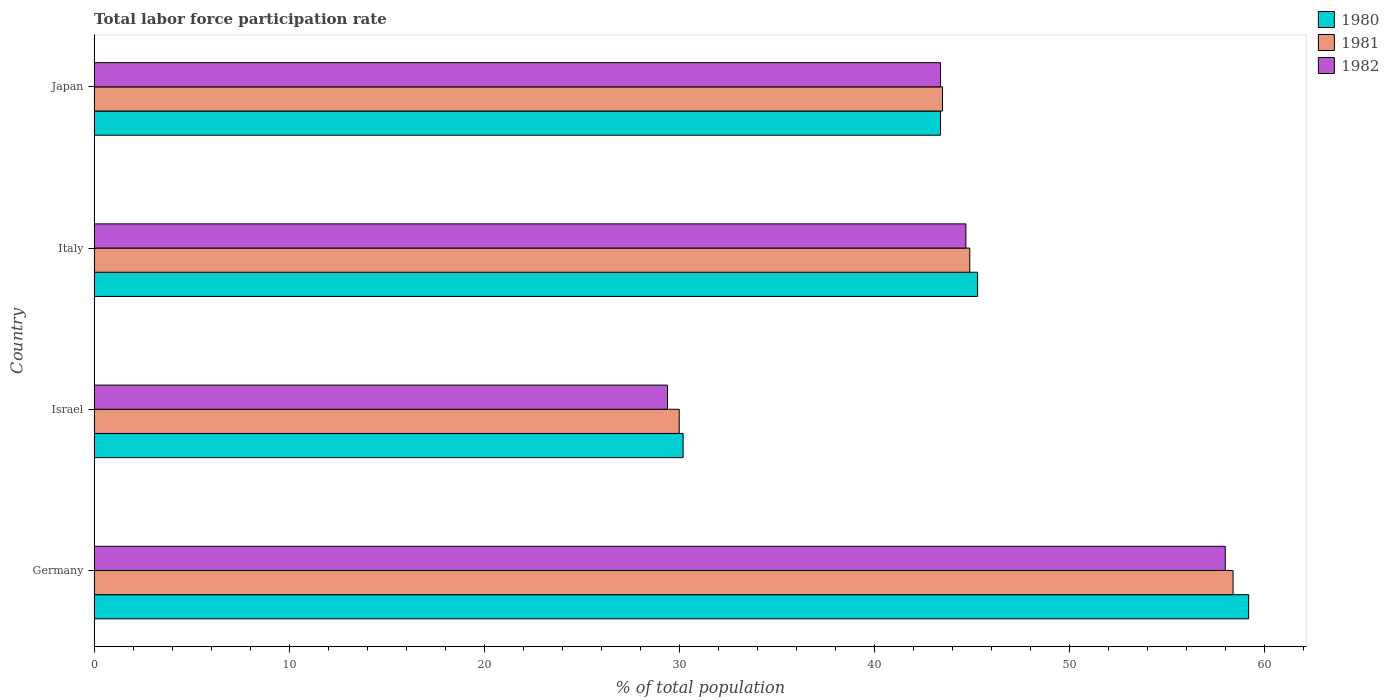How many different coloured bars are there?
Ensure brevity in your answer.  3. How many groups of bars are there?
Your answer should be compact. 4. Are the number of bars per tick equal to the number of legend labels?
Your answer should be very brief. Yes. How many bars are there on the 1st tick from the bottom?
Give a very brief answer. 3. In how many cases, is the number of bars for a given country not equal to the number of legend labels?
Give a very brief answer. 0. What is the total labor force participation rate in 1980 in Japan?
Offer a terse response. 43.4. Across all countries, what is the maximum total labor force participation rate in 1981?
Provide a succinct answer. 58.4. In which country was the total labor force participation rate in 1981 maximum?
Your response must be concise. Germany. What is the total total labor force participation rate in 1981 in the graph?
Keep it short and to the point. 176.8. What is the difference between the total labor force participation rate in 1982 in Germany and that in Japan?
Your answer should be very brief. 14.6. What is the difference between the total labor force participation rate in 1980 in Israel and the total labor force participation rate in 1982 in Italy?
Your response must be concise. -14.5. What is the average total labor force participation rate in 1980 per country?
Your answer should be very brief. 44.53. What is the difference between the total labor force participation rate in 1981 and total labor force participation rate in 1980 in Germany?
Offer a terse response. -0.8. What is the ratio of the total labor force participation rate in 1981 in Italy to that in Japan?
Your response must be concise. 1.03. Is the total labor force participation rate in 1980 in Germany less than that in Israel?
Provide a short and direct response. No. Is the difference between the total labor force participation rate in 1981 in Germany and Italy greater than the difference between the total labor force participation rate in 1980 in Germany and Italy?
Your response must be concise. No. What is the difference between the highest and the lowest total labor force participation rate in 1982?
Offer a terse response. 28.6. Is the sum of the total labor force participation rate in 1980 in Italy and Japan greater than the maximum total labor force participation rate in 1982 across all countries?
Make the answer very short. Yes. What does the 1st bar from the bottom in Germany represents?
Make the answer very short. 1980. Is it the case that in every country, the sum of the total labor force participation rate in 1981 and total labor force participation rate in 1980 is greater than the total labor force participation rate in 1982?
Provide a succinct answer. Yes. How many bars are there?
Make the answer very short. 12. Are all the bars in the graph horizontal?
Your answer should be compact. Yes. Are the values on the major ticks of X-axis written in scientific E-notation?
Give a very brief answer. No. Does the graph contain any zero values?
Your answer should be compact. No. Where does the legend appear in the graph?
Keep it short and to the point. Top right. How are the legend labels stacked?
Your response must be concise. Vertical. What is the title of the graph?
Make the answer very short. Total labor force participation rate. What is the label or title of the X-axis?
Keep it short and to the point. % of total population. What is the label or title of the Y-axis?
Your answer should be very brief. Country. What is the % of total population in 1980 in Germany?
Make the answer very short. 59.2. What is the % of total population of 1981 in Germany?
Make the answer very short. 58.4. What is the % of total population in 1982 in Germany?
Offer a very short reply. 58. What is the % of total population of 1980 in Israel?
Provide a short and direct response. 30.2. What is the % of total population in 1981 in Israel?
Your response must be concise. 30. What is the % of total population of 1982 in Israel?
Ensure brevity in your answer.  29.4. What is the % of total population of 1980 in Italy?
Your answer should be compact. 45.3. What is the % of total population of 1981 in Italy?
Keep it short and to the point. 44.9. What is the % of total population in 1982 in Italy?
Provide a short and direct response. 44.7. What is the % of total population of 1980 in Japan?
Your response must be concise. 43.4. What is the % of total population in 1981 in Japan?
Your answer should be very brief. 43.5. What is the % of total population of 1982 in Japan?
Provide a succinct answer. 43.4. Across all countries, what is the maximum % of total population in 1980?
Your response must be concise. 59.2. Across all countries, what is the maximum % of total population in 1981?
Provide a succinct answer. 58.4. Across all countries, what is the minimum % of total population of 1980?
Provide a short and direct response. 30.2. Across all countries, what is the minimum % of total population of 1982?
Offer a terse response. 29.4. What is the total % of total population of 1980 in the graph?
Give a very brief answer. 178.1. What is the total % of total population in 1981 in the graph?
Provide a succinct answer. 176.8. What is the total % of total population of 1982 in the graph?
Give a very brief answer. 175.5. What is the difference between the % of total population in 1980 in Germany and that in Israel?
Give a very brief answer. 29. What is the difference between the % of total population of 1981 in Germany and that in Israel?
Give a very brief answer. 28.4. What is the difference between the % of total population in 1982 in Germany and that in Israel?
Give a very brief answer. 28.6. What is the difference between the % of total population of 1980 in Germany and that in Italy?
Your response must be concise. 13.9. What is the difference between the % of total population of 1980 in Germany and that in Japan?
Provide a succinct answer. 15.8. What is the difference between the % of total population in 1981 in Germany and that in Japan?
Keep it short and to the point. 14.9. What is the difference between the % of total population in 1980 in Israel and that in Italy?
Provide a short and direct response. -15.1. What is the difference between the % of total population of 1981 in Israel and that in Italy?
Ensure brevity in your answer.  -14.9. What is the difference between the % of total population of 1982 in Israel and that in Italy?
Offer a very short reply. -15.3. What is the difference between the % of total population of 1980 in Israel and that in Japan?
Your response must be concise. -13.2. What is the difference between the % of total population in 1981 in Israel and that in Japan?
Give a very brief answer. -13.5. What is the difference between the % of total population in 1982 in Israel and that in Japan?
Provide a succinct answer. -14. What is the difference between the % of total population in 1981 in Italy and that in Japan?
Ensure brevity in your answer.  1.4. What is the difference between the % of total population in 1980 in Germany and the % of total population in 1981 in Israel?
Provide a short and direct response. 29.2. What is the difference between the % of total population of 1980 in Germany and the % of total population of 1982 in Israel?
Your response must be concise. 29.8. What is the difference between the % of total population in 1981 in Germany and the % of total population in 1982 in Israel?
Provide a succinct answer. 29. What is the difference between the % of total population of 1980 in Germany and the % of total population of 1981 in Italy?
Provide a succinct answer. 14.3. What is the difference between the % of total population of 1980 in Germany and the % of total population of 1982 in Italy?
Offer a very short reply. 14.5. What is the difference between the % of total population of 1980 in Germany and the % of total population of 1981 in Japan?
Ensure brevity in your answer.  15.7. What is the difference between the % of total population in 1981 in Germany and the % of total population in 1982 in Japan?
Your answer should be compact. 15. What is the difference between the % of total population in 1980 in Israel and the % of total population in 1981 in Italy?
Provide a succinct answer. -14.7. What is the difference between the % of total population of 1980 in Israel and the % of total population of 1982 in Italy?
Your answer should be compact. -14.5. What is the difference between the % of total population of 1981 in Israel and the % of total population of 1982 in Italy?
Your answer should be very brief. -14.7. What is the difference between the % of total population in 1980 in Israel and the % of total population in 1982 in Japan?
Give a very brief answer. -13.2. What is the difference between the % of total population in 1981 in Israel and the % of total population in 1982 in Japan?
Keep it short and to the point. -13.4. What is the difference between the % of total population of 1980 in Italy and the % of total population of 1982 in Japan?
Give a very brief answer. 1.9. What is the average % of total population in 1980 per country?
Your answer should be compact. 44.52. What is the average % of total population in 1981 per country?
Offer a terse response. 44.2. What is the average % of total population in 1982 per country?
Offer a terse response. 43.88. What is the difference between the % of total population of 1980 and % of total population of 1981 in Germany?
Provide a succinct answer. 0.8. What is the difference between the % of total population in 1980 and % of total population in 1981 in Israel?
Your answer should be compact. 0.2. What is the difference between the % of total population of 1980 and % of total population of 1981 in Italy?
Ensure brevity in your answer.  0.4. What is the difference between the % of total population of 1980 and % of total population of 1982 in Italy?
Offer a very short reply. 0.6. What is the difference between the % of total population in 1981 and % of total population in 1982 in Japan?
Offer a terse response. 0.1. What is the ratio of the % of total population in 1980 in Germany to that in Israel?
Ensure brevity in your answer.  1.96. What is the ratio of the % of total population in 1981 in Germany to that in Israel?
Your answer should be compact. 1.95. What is the ratio of the % of total population in 1982 in Germany to that in Israel?
Keep it short and to the point. 1.97. What is the ratio of the % of total population of 1980 in Germany to that in Italy?
Your answer should be very brief. 1.31. What is the ratio of the % of total population in 1981 in Germany to that in Italy?
Provide a succinct answer. 1.3. What is the ratio of the % of total population in 1982 in Germany to that in Italy?
Your answer should be very brief. 1.3. What is the ratio of the % of total population in 1980 in Germany to that in Japan?
Offer a terse response. 1.36. What is the ratio of the % of total population in 1981 in Germany to that in Japan?
Your response must be concise. 1.34. What is the ratio of the % of total population in 1982 in Germany to that in Japan?
Ensure brevity in your answer.  1.34. What is the ratio of the % of total population in 1981 in Israel to that in Italy?
Give a very brief answer. 0.67. What is the ratio of the % of total population in 1982 in Israel to that in Italy?
Your answer should be very brief. 0.66. What is the ratio of the % of total population in 1980 in Israel to that in Japan?
Your answer should be very brief. 0.7. What is the ratio of the % of total population in 1981 in Israel to that in Japan?
Provide a short and direct response. 0.69. What is the ratio of the % of total population of 1982 in Israel to that in Japan?
Offer a terse response. 0.68. What is the ratio of the % of total population of 1980 in Italy to that in Japan?
Give a very brief answer. 1.04. What is the ratio of the % of total population of 1981 in Italy to that in Japan?
Provide a short and direct response. 1.03. What is the ratio of the % of total population in 1982 in Italy to that in Japan?
Your answer should be compact. 1.03. What is the difference between the highest and the lowest % of total population in 1981?
Offer a terse response. 28.4. What is the difference between the highest and the lowest % of total population in 1982?
Keep it short and to the point. 28.6. 